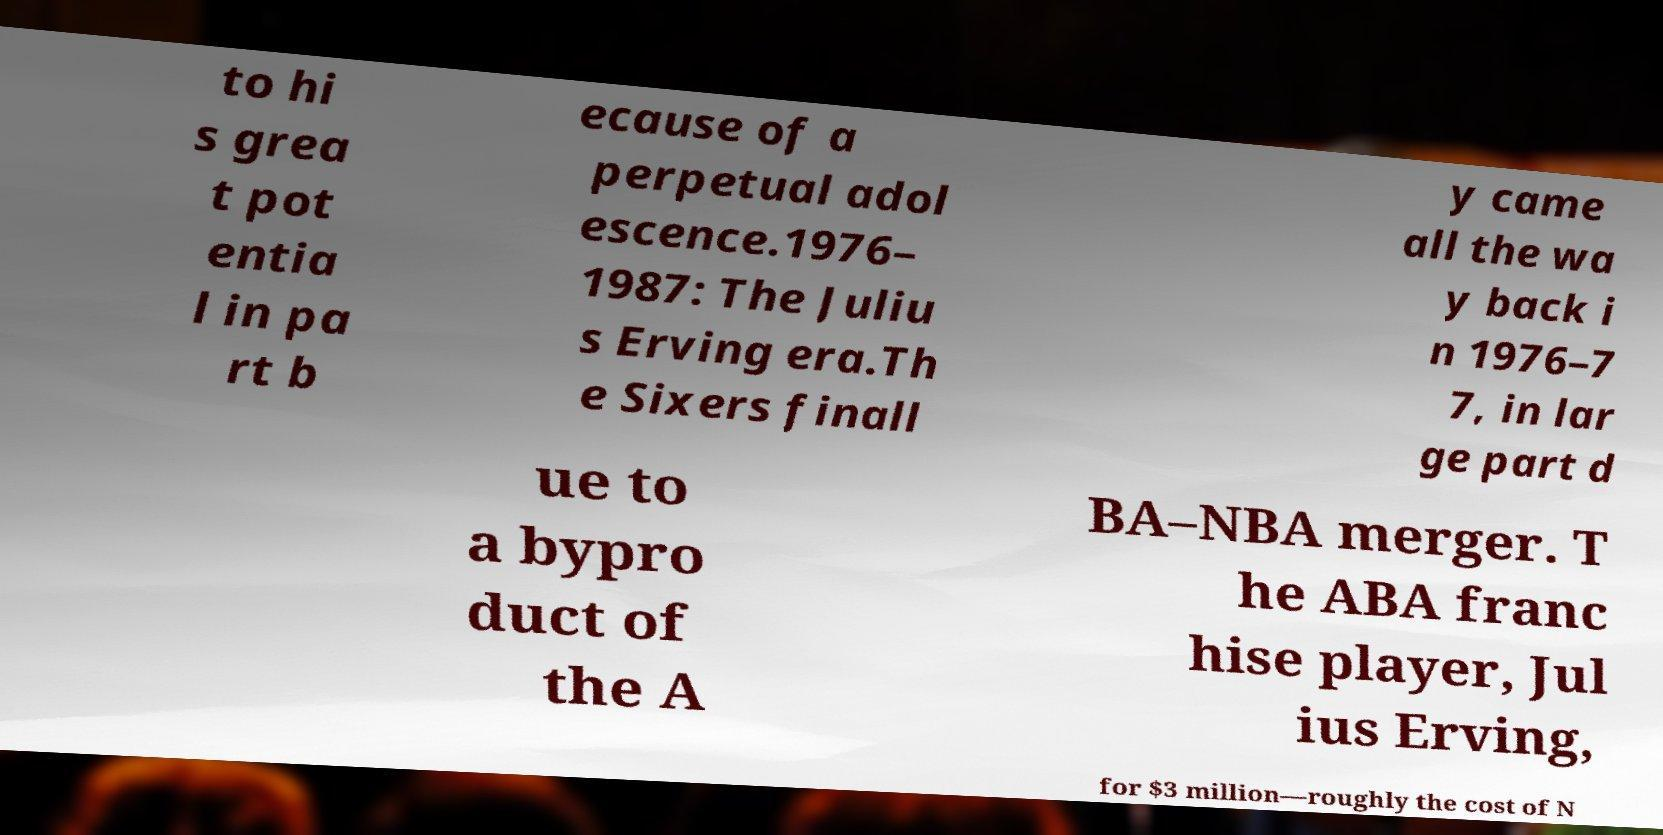Please identify and transcribe the text found in this image. to hi s grea t pot entia l in pa rt b ecause of a perpetual adol escence.1976– 1987: The Juliu s Erving era.Th e Sixers finall y came all the wa y back i n 1976–7 7, in lar ge part d ue to a bypro duct of the A BA–NBA merger. T he ABA franc hise player, Jul ius Erving, for $3 million—roughly the cost of N 